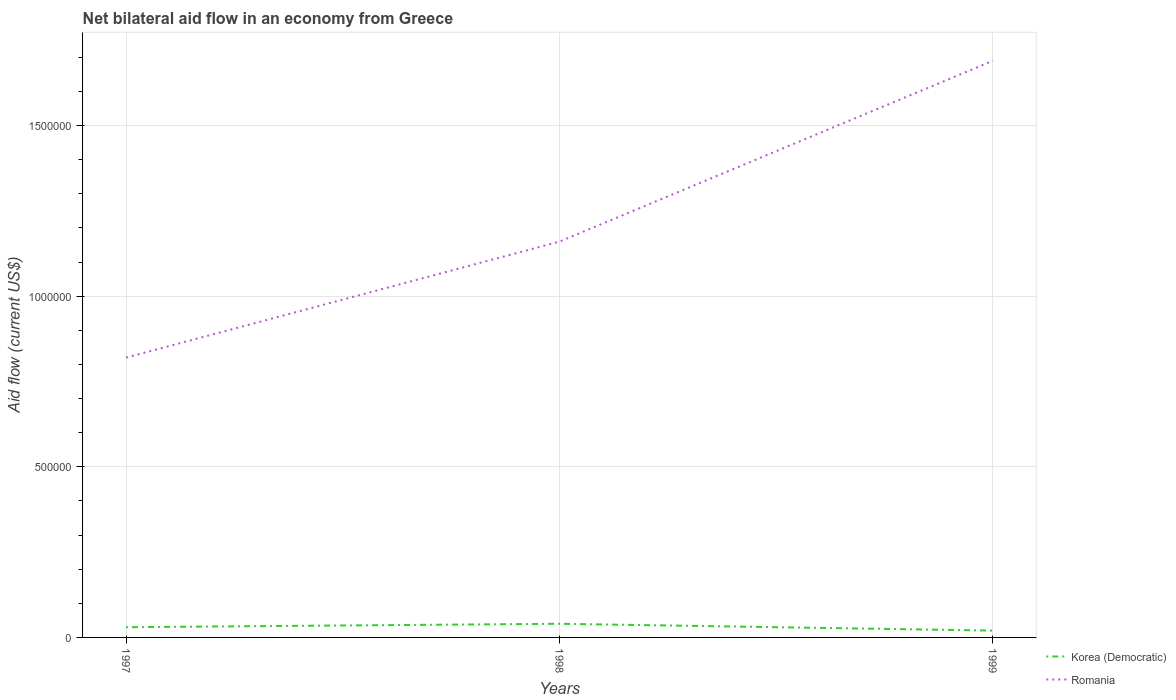Does the line corresponding to Korea (Democratic) intersect with the line corresponding to Romania?
Offer a very short reply. No. Is the number of lines equal to the number of legend labels?
Ensure brevity in your answer.  Yes. Across all years, what is the maximum net bilateral aid flow in Korea (Democratic)?
Your answer should be very brief. 2.00e+04. In which year was the net bilateral aid flow in Romania maximum?
Keep it short and to the point. 1997. What is the difference between the highest and the second highest net bilateral aid flow in Romania?
Provide a succinct answer. 8.70e+05. What is the difference between the highest and the lowest net bilateral aid flow in Romania?
Your response must be concise. 1. Is the net bilateral aid flow in Romania strictly greater than the net bilateral aid flow in Korea (Democratic) over the years?
Your answer should be very brief. No. What is the difference between two consecutive major ticks on the Y-axis?
Provide a succinct answer. 5.00e+05. Does the graph contain any zero values?
Keep it short and to the point. No. How many legend labels are there?
Ensure brevity in your answer.  2. What is the title of the graph?
Make the answer very short. Net bilateral aid flow in an economy from Greece. What is the label or title of the X-axis?
Make the answer very short. Years. What is the Aid flow (current US$) of Korea (Democratic) in 1997?
Your response must be concise. 3.00e+04. What is the Aid flow (current US$) of Romania in 1997?
Your answer should be very brief. 8.20e+05. What is the Aid flow (current US$) of Romania in 1998?
Provide a succinct answer. 1.16e+06. What is the Aid flow (current US$) in Romania in 1999?
Your answer should be compact. 1.69e+06. Across all years, what is the maximum Aid flow (current US$) in Korea (Democratic)?
Your answer should be very brief. 4.00e+04. Across all years, what is the maximum Aid flow (current US$) in Romania?
Provide a short and direct response. 1.69e+06. Across all years, what is the minimum Aid flow (current US$) in Korea (Democratic)?
Provide a succinct answer. 2.00e+04. Across all years, what is the minimum Aid flow (current US$) in Romania?
Make the answer very short. 8.20e+05. What is the total Aid flow (current US$) of Korea (Democratic) in the graph?
Give a very brief answer. 9.00e+04. What is the total Aid flow (current US$) in Romania in the graph?
Provide a short and direct response. 3.67e+06. What is the difference between the Aid flow (current US$) of Romania in 1997 and that in 1998?
Give a very brief answer. -3.40e+05. What is the difference between the Aid flow (current US$) of Korea (Democratic) in 1997 and that in 1999?
Offer a terse response. 10000. What is the difference between the Aid flow (current US$) in Romania in 1997 and that in 1999?
Your response must be concise. -8.70e+05. What is the difference between the Aid flow (current US$) of Korea (Democratic) in 1998 and that in 1999?
Your response must be concise. 2.00e+04. What is the difference between the Aid flow (current US$) in Romania in 1998 and that in 1999?
Your response must be concise. -5.30e+05. What is the difference between the Aid flow (current US$) of Korea (Democratic) in 1997 and the Aid flow (current US$) of Romania in 1998?
Offer a very short reply. -1.13e+06. What is the difference between the Aid flow (current US$) in Korea (Democratic) in 1997 and the Aid flow (current US$) in Romania in 1999?
Provide a short and direct response. -1.66e+06. What is the difference between the Aid flow (current US$) in Korea (Democratic) in 1998 and the Aid flow (current US$) in Romania in 1999?
Offer a terse response. -1.65e+06. What is the average Aid flow (current US$) of Korea (Democratic) per year?
Make the answer very short. 3.00e+04. What is the average Aid flow (current US$) of Romania per year?
Offer a terse response. 1.22e+06. In the year 1997, what is the difference between the Aid flow (current US$) in Korea (Democratic) and Aid flow (current US$) in Romania?
Ensure brevity in your answer.  -7.90e+05. In the year 1998, what is the difference between the Aid flow (current US$) in Korea (Democratic) and Aid flow (current US$) in Romania?
Give a very brief answer. -1.12e+06. In the year 1999, what is the difference between the Aid flow (current US$) of Korea (Democratic) and Aid flow (current US$) of Romania?
Ensure brevity in your answer.  -1.67e+06. What is the ratio of the Aid flow (current US$) of Korea (Democratic) in 1997 to that in 1998?
Offer a very short reply. 0.75. What is the ratio of the Aid flow (current US$) in Romania in 1997 to that in 1998?
Offer a terse response. 0.71. What is the ratio of the Aid flow (current US$) of Korea (Democratic) in 1997 to that in 1999?
Provide a short and direct response. 1.5. What is the ratio of the Aid flow (current US$) of Romania in 1997 to that in 1999?
Ensure brevity in your answer.  0.49. What is the ratio of the Aid flow (current US$) in Korea (Democratic) in 1998 to that in 1999?
Your response must be concise. 2. What is the ratio of the Aid flow (current US$) in Romania in 1998 to that in 1999?
Provide a short and direct response. 0.69. What is the difference between the highest and the second highest Aid flow (current US$) of Romania?
Offer a terse response. 5.30e+05. What is the difference between the highest and the lowest Aid flow (current US$) in Korea (Democratic)?
Your answer should be compact. 2.00e+04. What is the difference between the highest and the lowest Aid flow (current US$) in Romania?
Provide a short and direct response. 8.70e+05. 